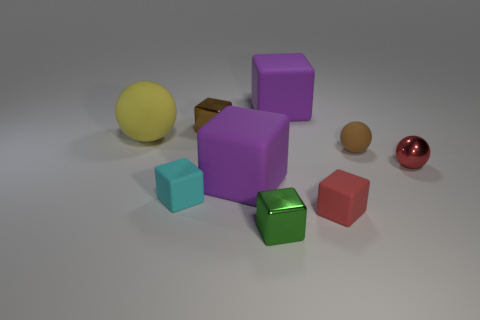Subtract all tiny spheres. How many spheres are left? 1 Subtract 3 balls. How many balls are left? 0 Subtract all metal cubes. Subtract all small objects. How many objects are left? 1 Add 5 green metal blocks. How many green metal blocks are left? 6 Add 9 large yellow rubber balls. How many large yellow rubber balls exist? 10 Subtract all green blocks. How many blocks are left? 5 Subtract 0 cyan cylinders. How many objects are left? 9 Subtract all balls. How many objects are left? 6 Subtract all purple blocks. Subtract all cyan spheres. How many blocks are left? 4 Subtract all red cubes. How many yellow balls are left? 1 